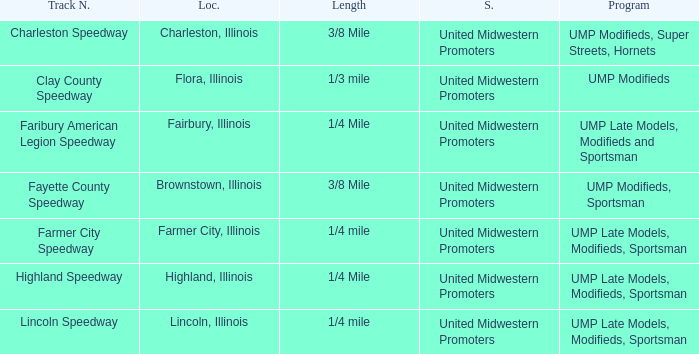What programs were held in charleston, illinois? UMP Modifieds, Super Streets, Hornets. 